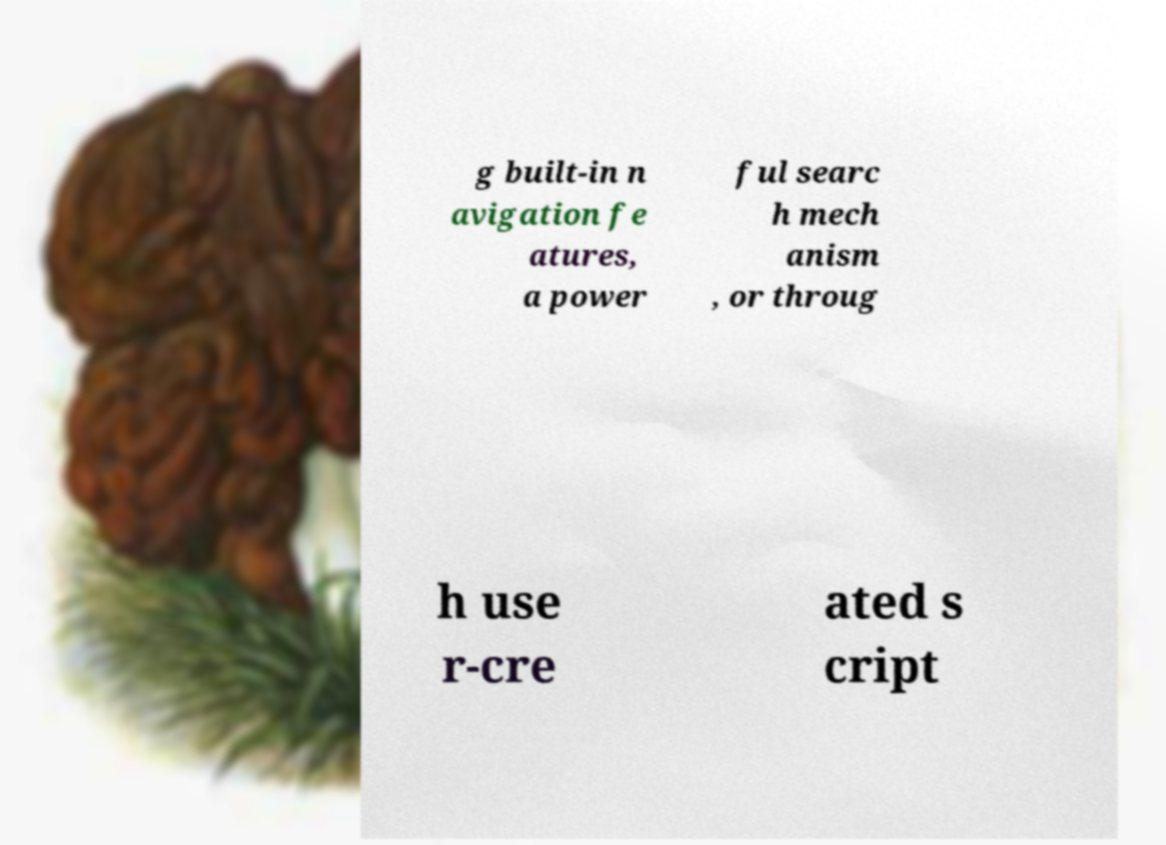Please identify and transcribe the text found in this image. g built-in n avigation fe atures, a power ful searc h mech anism , or throug h use r-cre ated s cript 